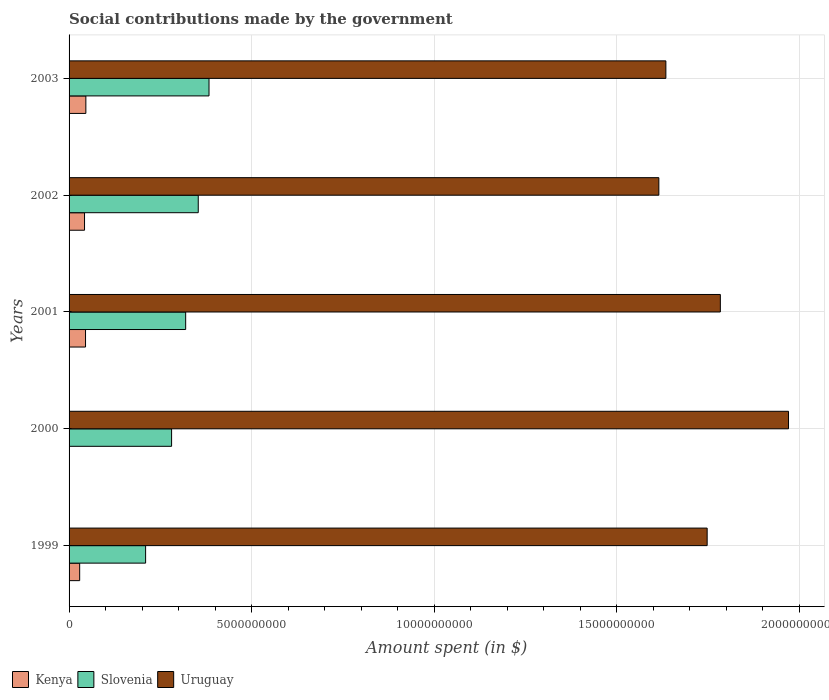How many different coloured bars are there?
Offer a terse response. 3. Are the number of bars per tick equal to the number of legend labels?
Offer a terse response. Yes. Are the number of bars on each tick of the Y-axis equal?
Provide a succinct answer. Yes. What is the amount spent on social contributions in Kenya in 2002?
Provide a short and direct response. 4.24e+08. Across all years, what is the maximum amount spent on social contributions in Kenya?
Offer a very short reply. 4.60e+08. Across all years, what is the minimum amount spent on social contributions in Uruguay?
Offer a very short reply. 1.62e+1. What is the total amount spent on social contributions in Uruguay in the graph?
Your answer should be very brief. 8.75e+1. What is the difference between the amount spent on social contributions in Uruguay in 2000 and that in 2002?
Your response must be concise. 3.55e+09. What is the difference between the amount spent on social contributions in Uruguay in 2000 and the amount spent on social contributions in Kenya in 2001?
Offer a very short reply. 1.93e+1. What is the average amount spent on social contributions in Slovenia per year?
Your response must be concise. 3.09e+09. In the year 1999, what is the difference between the amount spent on social contributions in Slovenia and amount spent on social contributions in Uruguay?
Offer a very short reply. -1.54e+1. In how many years, is the amount spent on social contributions in Uruguay greater than 4000000000 $?
Offer a very short reply. 5. What is the ratio of the amount spent on social contributions in Kenya in 1999 to that in 2000?
Offer a terse response. 145.3. What is the difference between the highest and the second highest amount spent on social contributions in Uruguay?
Your answer should be very brief. 1.87e+09. What is the difference between the highest and the lowest amount spent on social contributions in Slovenia?
Your response must be concise. 1.74e+09. In how many years, is the amount spent on social contributions in Kenya greater than the average amount spent on social contributions in Kenya taken over all years?
Make the answer very short. 3. What does the 3rd bar from the top in 2000 represents?
Give a very brief answer. Kenya. What does the 3rd bar from the bottom in 1999 represents?
Your response must be concise. Uruguay. Is it the case that in every year, the sum of the amount spent on social contributions in Slovenia and amount spent on social contributions in Kenya is greater than the amount spent on social contributions in Uruguay?
Your answer should be very brief. No. How many bars are there?
Provide a short and direct response. 15. Are all the bars in the graph horizontal?
Your response must be concise. Yes. Does the graph contain grids?
Provide a succinct answer. Yes. Where does the legend appear in the graph?
Offer a terse response. Bottom left. How many legend labels are there?
Your answer should be very brief. 3. What is the title of the graph?
Your answer should be compact. Social contributions made by the government. Does "Vietnam" appear as one of the legend labels in the graph?
Ensure brevity in your answer.  No. What is the label or title of the X-axis?
Offer a very short reply. Amount spent (in $). What is the label or title of the Y-axis?
Offer a very short reply. Years. What is the Amount spent (in $) of Kenya in 1999?
Keep it short and to the point. 2.91e+08. What is the Amount spent (in $) in Slovenia in 1999?
Ensure brevity in your answer.  2.10e+09. What is the Amount spent (in $) of Uruguay in 1999?
Give a very brief answer. 1.75e+1. What is the Amount spent (in $) in Kenya in 2000?
Provide a succinct answer. 2.00e+06. What is the Amount spent (in $) of Slovenia in 2000?
Your answer should be very brief. 2.81e+09. What is the Amount spent (in $) of Uruguay in 2000?
Your answer should be compact. 1.97e+1. What is the Amount spent (in $) of Kenya in 2001?
Make the answer very short. 4.51e+08. What is the Amount spent (in $) in Slovenia in 2001?
Your answer should be compact. 3.19e+09. What is the Amount spent (in $) of Uruguay in 2001?
Keep it short and to the point. 1.78e+1. What is the Amount spent (in $) in Kenya in 2002?
Provide a short and direct response. 4.24e+08. What is the Amount spent (in $) in Slovenia in 2002?
Ensure brevity in your answer.  3.54e+09. What is the Amount spent (in $) in Uruguay in 2002?
Keep it short and to the point. 1.62e+1. What is the Amount spent (in $) in Kenya in 2003?
Keep it short and to the point. 4.60e+08. What is the Amount spent (in $) of Slovenia in 2003?
Offer a very short reply. 3.83e+09. What is the Amount spent (in $) in Uruguay in 2003?
Make the answer very short. 1.64e+1. Across all years, what is the maximum Amount spent (in $) of Kenya?
Your answer should be compact. 4.60e+08. Across all years, what is the maximum Amount spent (in $) of Slovenia?
Ensure brevity in your answer.  3.83e+09. Across all years, what is the maximum Amount spent (in $) of Uruguay?
Keep it short and to the point. 1.97e+1. Across all years, what is the minimum Amount spent (in $) in Slovenia?
Give a very brief answer. 2.10e+09. Across all years, what is the minimum Amount spent (in $) in Uruguay?
Give a very brief answer. 1.62e+1. What is the total Amount spent (in $) in Kenya in the graph?
Your answer should be compact. 1.63e+09. What is the total Amount spent (in $) in Slovenia in the graph?
Give a very brief answer. 1.55e+1. What is the total Amount spent (in $) of Uruguay in the graph?
Make the answer very short. 8.75e+1. What is the difference between the Amount spent (in $) of Kenya in 1999 and that in 2000?
Ensure brevity in your answer.  2.89e+08. What is the difference between the Amount spent (in $) of Slovenia in 1999 and that in 2000?
Make the answer very short. -7.12e+08. What is the difference between the Amount spent (in $) in Uruguay in 1999 and that in 2000?
Offer a very short reply. -2.23e+09. What is the difference between the Amount spent (in $) in Kenya in 1999 and that in 2001?
Offer a terse response. -1.60e+08. What is the difference between the Amount spent (in $) in Slovenia in 1999 and that in 2001?
Offer a terse response. -1.10e+09. What is the difference between the Amount spent (in $) of Uruguay in 1999 and that in 2001?
Provide a succinct answer. -3.61e+08. What is the difference between the Amount spent (in $) of Kenya in 1999 and that in 2002?
Provide a short and direct response. -1.33e+08. What is the difference between the Amount spent (in $) in Slovenia in 1999 and that in 2002?
Keep it short and to the point. -1.44e+09. What is the difference between the Amount spent (in $) in Uruguay in 1999 and that in 2002?
Provide a succinct answer. 1.32e+09. What is the difference between the Amount spent (in $) of Kenya in 1999 and that in 2003?
Give a very brief answer. -1.69e+08. What is the difference between the Amount spent (in $) in Slovenia in 1999 and that in 2003?
Give a very brief answer. -1.74e+09. What is the difference between the Amount spent (in $) in Uruguay in 1999 and that in 2003?
Your response must be concise. 1.13e+09. What is the difference between the Amount spent (in $) in Kenya in 2000 and that in 2001?
Offer a very short reply. -4.49e+08. What is the difference between the Amount spent (in $) of Slovenia in 2000 and that in 2001?
Give a very brief answer. -3.85e+08. What is the difference between the Amount spent (in $) in Uruguay in 2000 and that in 2001?
Give a very brief answer. 1.87e+09. What is the difference between the Amount spent (in $) of Kenya in 2000 and that in 2002?
Your answer should be compact. -4.22e+08. What is the difference between the Amount spent (in $) of Slovenia in 2000 and that in 2002?
Provide a succinct answer. -7.30e+08. What is the difference between the Amount spent (in $) in Uruguay in 2000 and that in 2002?
Provide a short and direct response. 3.55e+09. What is the difference between the Amount spent (in $) in Kenya in 2000 and that in 2003?
Provide a succinct answer. -4.58e+08. What is the difference between the Amount spent (in $) of Slovenia in 2000 and that in 2003?
Provide a succinct answer. -1.02e+09. What is the difference between the Amount spent (in $) of Uruguay in 2000 and that in 2003?
Provide a short and direct response. 3.36e+09. What is the difference between the Amount spent (in $) in Kenya in 2001 and that in 2002?
Provide a short and direct response. 2.73e+07. What is the difference between the Amount spent (in $) in Slovenia in 2001 and that in 2002?
Make the answer very short. -3.45e+08. What is the difference between the Amount spent (in $) in Uruguay in 2001 and that in 2002?
Give a very brief answer. 1.68e+09. What is the difference between the Amount spent (in $) in Kenya in 2001 and that in 2003?
Your answer should be compact. -8.90e+06. What is the difference between the Amount spent (in $) in Slovenia in 2001 and that in 2003?
Make the answer very short. -6.39e+08. What is the difference between the Amount spent (in $) of Uruguay in 2001 and that in 2003?
Your answer should be very brief. 1.49e+09. What is the difference between the Amount spent (in $) in Kenya in 2002 and that in 2003?
Ensure brevity in your answer.  -3.62e+07. What is the difference between the Amount spent (in $) in Slovenia in 2002 and that in 2003?
Ensure brevity in your answer.  -2.95e+08. What is the difference between the Amount spent (in $) in Uruguay in 2002 and that in 2003?
Offer a very short reply. -1.92e+08. What is the difference between the Amount spent (in $) in Kenya in 1999 and the Amount spent (in $) in Slovenia in 2000?
Your response must be concise. -2.52e+09. What is the difference between the Amount spent (in $) of Kenya in 1999 and the Amount spent (in $) of Uruguay in 2000?
Your response must be concise. -1.94e+1. What is the difference between the Amount spent (in $) of Slovenia in 1999 and the Amount spent (in $) of Uruguay in 2000?
Make the answer very short. -1.76e+1. What is the difference between the Amount spent (in $) in Kenya in 1999 and the Amount spent (in $) in Slovenia in 2001?
Offer a very short reply. -2.90e+09. What is the difference between the Amount spent (in $) of Kenya in 1999 and the Amount spent (in $) of Uruguay in 2001?
Offer a very short reply. -1.76e+1. What is the difference between the Amount spent (in $) of Slovenia in 1999 and the Amount spent (in $) of Uruguay in 2001?
Offer a terse response. -1.57e+1. What is the difference between the Amount spent (in $) in Kenya in 1999 and the Amount spent (in $) in Slovenia in 2002?
Your answer should be compact. -3.25e+09. What is the difference between the Amount spent (in $) of Kenya in 1999 and the Amount spent (in $) of Uruguay in 2002?
Offer a very short reply. -1.59e+1. What is the difference between the Amount spent (in $) of Slovenia in 1999 and the Amount spent (in $) of Uruguay in 2002?
Your answer should be compact. -1.41e+1. What is the difference between the Amount spent (in $) of Kenya in 1999 and the Amount spent (in $) of Slovenia in 2003?
Keep it short and to the point. -3.54e+09. What is the difference between the Amount spent (in $) in Kenya in 1999 and the Amount spent (in $) in Uruguay in 2003?
Your response must be concise. -1.61e+1. What is the difference between the Amount spent (in $) in Slovenia in 1999 and the Amount spent (in $) in Uruguay in 2003?
Your answer should be compact. -1.43e+1. What is the difference between the Amount spent (in $) of Kenya in 2000 and the Amount spent (in $) of Slovenia in 2001?
Offer a terse response. -3.19e+09. What is the difference between the Amount spent (in $) in Kenya in 2000 and the Amount spent (in $) in Uruguay in 2001?
Provide a short and direct response. -1.78e+1. What is the difference between the Amount spent (in $) in Slovenia in 2000 and the Amount spent (in $) in Uruguay in 2001?
Offer a terse response. -1.50e+1. What is the difference between the Amount spent (in $) in Kenya in 2000 and the Amount spent (in $) in Slovenia in 2002?
Offer a terse response. -3.54e+09. What is the difference between the Amount spent (in $) of Kenya in 2000 and the Amount spent (in $) of Uruguay in 2002?
Provide a short and direct response. -1.62e+1. What is the difference between the Amount spent (in $) of Slovenia in 2000 and the Amount spent (in $) of Uruguay in 2002?
Provide a succinct answer. -1.33e+1. What is the difference between the Amount spent (in $) in Kenya in 2000 and the Amount spent (in $) in Slovenia in 2003?
Give a very brief answer. -3.83e+09. What is the difference between the Amount spent (in $) in Kenya in 2000 and the Amount spent (in $) in Uruguay in 2003?
Keep it short and to the point. -1.63e+1. What is the difference between the Amount spent (in $) of Slovenia in 2000 and the Amount spent (in $) of Uruguay in 2003?
Your answer should be compact. -1.35e+1. What is the difference between the Amount spent (in $) of Kenya in 2001 and the Amount spent (in $) of Slovenia in 2002?
Ensure brevity in your answer.  -3.09e+09. What is the difference between the Amount spent (in $) of Kenya in 2001 and the Amount spent (in $) of Uruguay in 2002?
Keep it short and to the point. -1.57e+1. What is the difference between the Amount spent (in $) of Slovenia in 2001 and the Amount spent (in $) of Uruguay in 2002?
Your answer should be very brief. -1.30e+1. What is the difference between the Amount spent (in $) in Kenya in 2001 and the Amount spent (in $) in Slovenia in 2003?
Provide a succinct answer. -3.38e+09. What is the difference between the Amount spent (in $) in Kenya in 2001 and the Amount spent (in $) in Uruguay in 2003?
Provide a short and direct response. -1.59e+1. What is the difference between the Amount spent (in $) of Slovenia in 2001 and the Amount spent (in $) of Uruguay in 2003?
Provide a short and direct response. -1.32e+1. What is the difference between the Amount spent (in $) in Kenya in 2002 and the Amount spent (in $) in Slovenia in 2003?
Your response must be concise. -3.41e+09. What is the difference between the Amount spent (in $) of Kenya in 2002 and the Amount spent (in $) of Uruguay in 2003?
Your answer should be very brief. -1.59e+1. What is the difference between the Amount spent (in $) in Slovenia in 2002 and the Amount spent (in $) in Uruguay in 2003?
Your answer should be very brief. -1.28e+1. What is the average Amount spent (in $) in Kenya per year?
Offer a very short reply. 3.25e+08. What is the average Amount spent (in $) in Slovenia per year?
Make the answer very short. 3.09e+09. What is the average Amount spent (in $) of Uruguay per year?
Offer a terse response. 1.75e+1. In the year 1999, what is the difference between the Amount spent (in $) of Kenya and Amount spent (in $) of Slovenia?
Your response must be concise. -1.81e+09. In the year 1999, what is the difference between the Amount spent (in $) in Kenya and Amount spent (in $) in Uruguay?
Make the answer very short. -1.72e+1. In the year 1999, what is the difference between the Amount spent (in $) of Slovenia and Amount spent (in $) of Uruguay?
Provide a succinct answer. -1.54e+1. In the year 2000, what is the difference between the Amount spent (in $) in Kenya and Amount spent (in $) in Slovenia?
Offer a very short reply. -2.81e+09. In the year 2000, what is the difference between the Amount spent (in $) of Kenya and Amount spent (in $) of Uruguay?
Give a very brief answer. -1.97e+1. In the year 2000, what is the difference between the Amount spent (in $) of Slovenia and Amount spent (in $) of Uruguay?
Provide a succinct answer. -1.69e+1. In the year 2001, what is the difference between the Amount spent (in $) in Kenya and Amount spent (in $) in Slovenia?
Offer a terse response. -2.74e+09. In the year 2001, what is the difference between the Amount spent (in $) in Kenya and Amount spent (in $) in Uruguay?
Give a very brief answer. -1.74e+1. In the year 2001, what is the difference between the Amount spent (in $) in Slovenia and Amount spent (in $) in Uruguay?
Give a very brief answer. -1.46e+1. In the year 2002, what is the difference between the Amount spent (in $) in Kenya and Amount spent (in $) in Slovenia?
Your answer should be very brief. -3.12e+09. In the year 2002, what is the difference between the Amount spent (in $) of Kenya and Amount spent (in $) of Uruguay?
Your response must be concise. -1.57e+1. In the year 2002, what is the difference between the Amount spent (in $) in Slovenia and Amount spent (in $) in Uruguay?
Make the answer very short. -1.26e+1. In the year 2003, what is the difference between the Amount spent (in $) of Kenya and Amount spent (in $) of Slovenia?
Offer a terse response. -3.37e+09. In the year 2003, what is the difference between the Amount spent (in $) in Kenya and Amount spent (in $) in Uruguay?
Ensure brevity in your answer.  -1.59e+1. In the year 2003, what is the difference between the Amount spent (in $) in Slovenia and Amount spent (in $) in Uruguay?
Your answer should be very brief. -1.25e+1. What is the ratio of the Amount spent (in $) in Kenya in 1999 to that in 2000?
Your answer should be compact. 145.3. What is the ratio of the Amount spent (in $) of Slovenia in 1999 to that in 2000?
Make the answer very short. 0.75. What is the ratio of the Amount spent (in $) in Uruguay in 1999 to that in 2000?
Your answer should be compact. 0.89. What is the ratio of the Amount spent (in $) in Kenya in 1999 to that in 2001?
Provide a succinct answer. 0.64. What is the ratio of the Amount spent (in $) in Slovenia in 1999 to that in 2001?
Offer a very short reply. 0.66. What is the ratio of the Amount spent (in $) in Uruguay in 1999 to that in 2001?
Keep it short and to the point. 0.98. What is the ratio of the Amount spent (in $) in Kenya in 1999 to that in 2002?
Provide a short and direct response. 0.69. What is the ratio of the Amount spent (in $) in Slovenia in 1999 to that in 2002?
Provide a short and direct response. 0.59. What is the ratio of the Amount spent (in $) in Uruguay in 1999 to that in 2002?
Offer a very short reply. 1.08. What is the ratio of the Amount spent (in $) of Kenya in 1999 to that in 2003?
Your answer should be very brief. 0.63. What is the ratio of the Amount spent (in $) in Slovenia in 1999 to that in 2003?
Ensure brevity in your answer.  0.55. What is the ratio of the Amount spent (in $) in Uruguay in 1999 to that in 2003?
Keep it short and to the point. 1.07. What is the ratio of the Amount spent (in $) in Kenya in 2000 to that in 2001?
Provide a short and direct response. 0. What is the ratio of the Amount spent (in $) of Slovenia in 2000 to that in 2001?
Make the answer very short. 0.88. What is the ratio of the Amount spent (in $) of Uruguay in 2000 to that in 2001?
Give a very brief answer. 1.1. What is the ratio of the Amount spent (in $) of Kenya in 2000 to that in 2002?
Provide a short and direct response. 0. What is the ratio of the Amount spent (in $) in Slovenia in 2000 to that in 2002?
Keep it short and to the point. 0.79. What is the ratio of the Amount spent (in $) of Uruguay in 2000 to that in 2002?
Your answer should be compact. 1.22. What is the ratio of the Amount spent (in $) in Kenya in 2000 to that in 2003?
Provide a short and direct response. 0. What is the ratio of the Amount spent (in $) in Slovenia in 2000 to that in 2003?
Keep it short and to the point. 0.73. What is the ratio of the Amount spent (in $) in Uruguay in 2000 to that in 2003?
Make the answer very short. 1.21. What is the ratio of the Amount spent (in $) of Kenya in 2001 to that in 2002?
Give a very brief answer. 1.06. What is the ratio of the Amount spent (in $) of Slovenia in 2001 to that in 2002?
Your answer should be very brief. 0.9. What is the ratio of the Amount spent (in $) in Uruguay in 2001 to that in 2002?
Your response must be concise. 1.1. What is the ratio of the Amount spent (in $) of Kenya in 2001 to that in 2003?
Your answer should be very brief. 0.98. What is the ratio of the Amount spent (in $) in Slovenia in 2001 to that in 2003?
Keep it short and to the point. 0.83. What is the ratio of the Amount spent (in $) in Uruguay in 2001 to that in 2003?
Keep it short and to the point. 1.09. What is the ratio of the Amount spent (in $) in Kenya in 2002 to that in 2003?
Offer a very short reply. 0.92. What is the difference between the highest and the second highest Amount spent (in $) of Kenya?
Your response must be concise. 8.90e+06. What is the difference between the highest and the second highest Amount spent (in $) in Slovenia?
Provide a succinct answer. 2.95e+08. What is the difference between the highest and the second highest Amount spent (in $) of Uruguay?
Your response must be concise. 1.87e+09. What is the difference between the highest and the lowest Amount spent (in $) in Kenya?
Your answer should be compact. 4.58e+08. What is the difference between the highest and the lowest Amount spent (in $) in Slovenia?
Provide a short and direct response. 1.74e+09. What is the difference between the highest and the lowest Amount spent (in $) of Uruguay?
Your answer should be compact. 3.55e+09. 